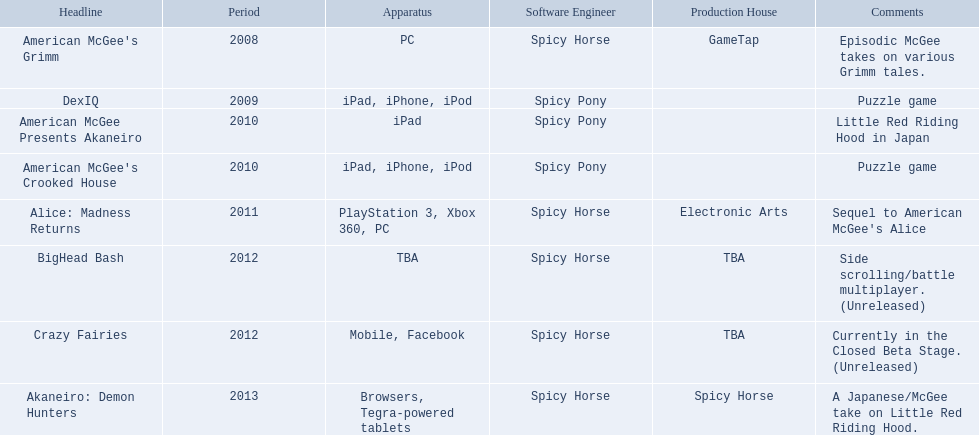What are all of the game titles? American McGee's Grimm, DexIQ, American McGee Presents Akaneiro, American McGee's Crooked House, Alice: Madness Returns, BigHead Bash, Crazy Fairies, Akaneiro: Demon Hunters. Which developer developed a game in 2011? Spicy Horse. Who published this game in 2011 Electronic Arts. What was the name of this published game in 2011? Alice: Madness Returns. 